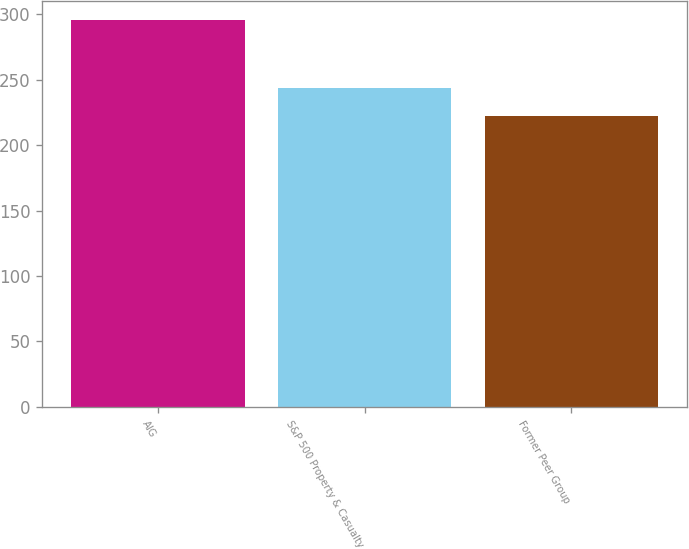Convert chart. <chart><loc_0><loc_0><loc_500><loc_500><bar_chart><fcel>AIG<fcel>S&P 500 Property & Casualty<fcel>Former Peer Group<nl><fcel>295.72<fcel>243.65<fcel>222.68<nl></chart> 